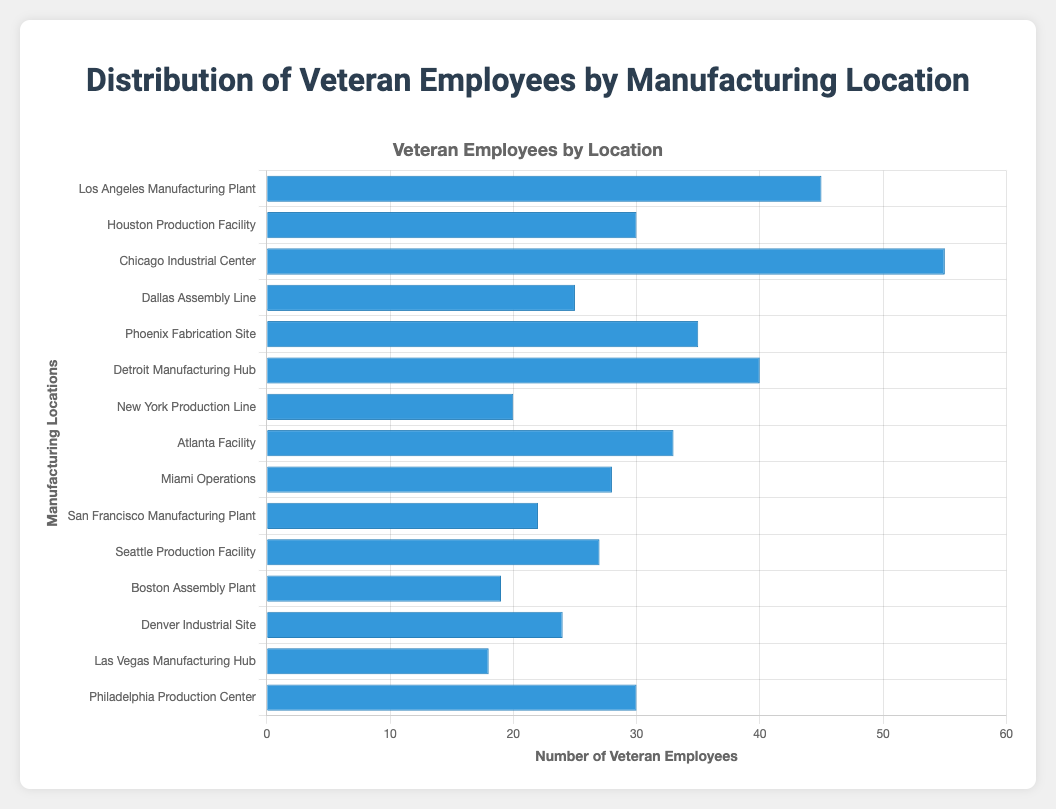Which location has the highest number of veteran employees? By examining the length of the bars, the Chicago Industrial Center has the longest bar, indicating it has the highest number of veteran employees, which is 55.
Answer: Chicago Industrial Center Which location has the fewest number of veteran employees? By looking at the shortest bar, the Las Vegas Manufacturing Hub has the fewest number of veteran employees, which is 18.
Answer: Las Vegas Manufacturing Hub How many locations have more than 30 veteran employees? Count the number of bars that extend beyond the 30-employee mark. There are six such locations: Los Angeles Manufacturing Plant, Chicago Industrial Center, Phoenix Fabrication Site, Detroit Manufacturing Hub, Atlanta Facility, and Houston Production Facility.
Answer: 6 What's the total number of veteran employees in Los Angeles and Chicago combined? Add the number of veteran employees in Los Angeles (45) and Chicago (55). The total is 45 + 55 = 100.
Answer: 100 Which location has more veteran employees: Detroit Manufacturing Hub or Miami Operations? Compare the lengths of the bars for Detroit Manufacturing Hub (40) and Miami Operations (28). Detroit Manufacturing Hub has more veteran employees.
Answer: Detroit Manufacturing Hub What is the average number of veteran employees across all locations? To find the average, sum up all the veteran employees and divide by the number of locations. The total sum is 420 (45 + 30 + 55 + 25 + 35 + 40 + 20 + 33 + 28 + 22 + 27 + 19 + 24 + 18 + 30). Since there are 15 locations, the average is 420 / 15 = 28.
Answer: 28 How many more veteran employees does Chicago Industrial Center have compared to the Denver Industrial Site? Subtract the number of veteran employees in Denver (24) from Chicago (55). The difference is 55 - 24 = 31.
Answer: 31 Which locations have exactly 30 veteran employees? Identify the bars with the value of 30. There are two locations: Houston Production Facility and Philadelphia Production Center.
Answer: Houston Production Facility, Philadelphia Production Center Are there more veteran employees in Phoenix Fabrication Site or Dallas Assembly Line? Compare the lengths of the bars for Phoenix Fabrication Site (35) and Dallas Assembly Line (25). Phoenix Fabrication Site has more veteran employees.
Answer: Phoenix Fabrication Site What is the combined number of veteran employees in New York Production Line and Boston Assembly Plant? Sum the number of veteran employees in New York (20) and Boston (19). The total is 20 + 19 = 39.
Answer: 39 